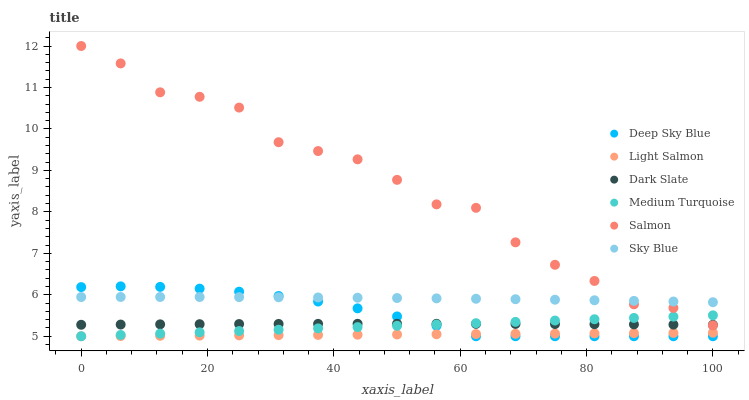Does Light Salmon have the minimum area under the curve?
Answer yes or no. Yes. Does Salmon have the maximum area under the curve?
Answer yes or no. Yes. Does Deep Sky Blue have the minimum area under the curve?
Answer yes or no. No. Does Deep Sky Blue have the maximum area under the curve?
Answer yes or no. No. Is Light Salmon the smoothest?
Answer yes or no. Yes. Is Salmon the roughest?
Answer yes or no. Yes. Is Deep Sky Blue the smoothest?
Answer yes or no. No. Is Deep Sky Blue the roughest?
Answer yes or no. No. Does Light Salmon have the lowest value?
Answer yes or no. Yes. Does Salmon have the lowest value?
Answer yes or no. No. Does Salmon have the highest value?
Answer yes or no. Yes. Does Deep Sky Blue have the highest value?
Answer yes or no. No. Is Light Salmon less than Dark Slate?
Answer yes or no. Yes. Is Sky Blue greater than Light Salmon?
Answer yes or no. Yes. Does Light Salmon intersect Deep Sky Blue?
Answer yes or no. Yes. Is Light Salmon less than Deep Sky Blue?
Answer yes or no. No. Is Light Salmon greater than Deep Sky Blue?
Answer yes or no. No. Does Light Salmon intersect Dark Slate?
Answer yes or no. No. 